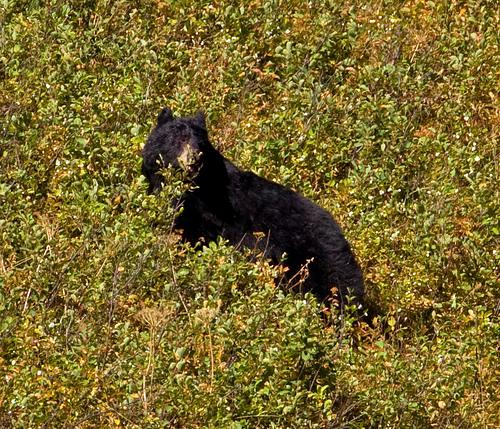Question: where was the photo taken?
Choices:
A. At a park.
B. At the beach.
C. At a court.
D. In a field.
Answer with the letter. Answer: D Question: what color is the grass?
Choices:
A. Blue.
B. Green.
C. Brown.
D. Yellow.
Answer with the letter. Answer: C Question: what animal is standing in the field?
Choices:
A. Wolf.
B. Bear.
C. Dog.
D. Sheep.
Answer with the letter. Answer: B 